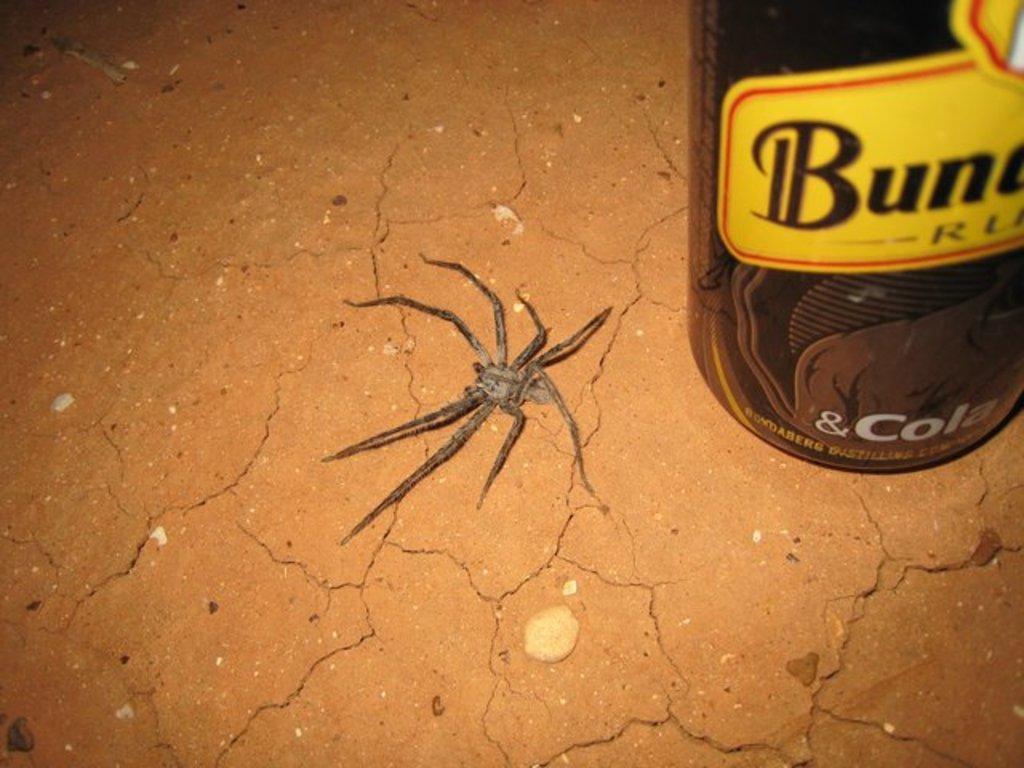Can you describe this image briefly? In this image in the center there is one spider and on the right side there is one bottle, and in the background there is floor. 